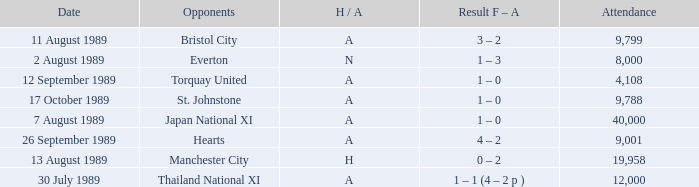When did Manchester United play against Bristol City with an H/A of A? 11 August 1989. 